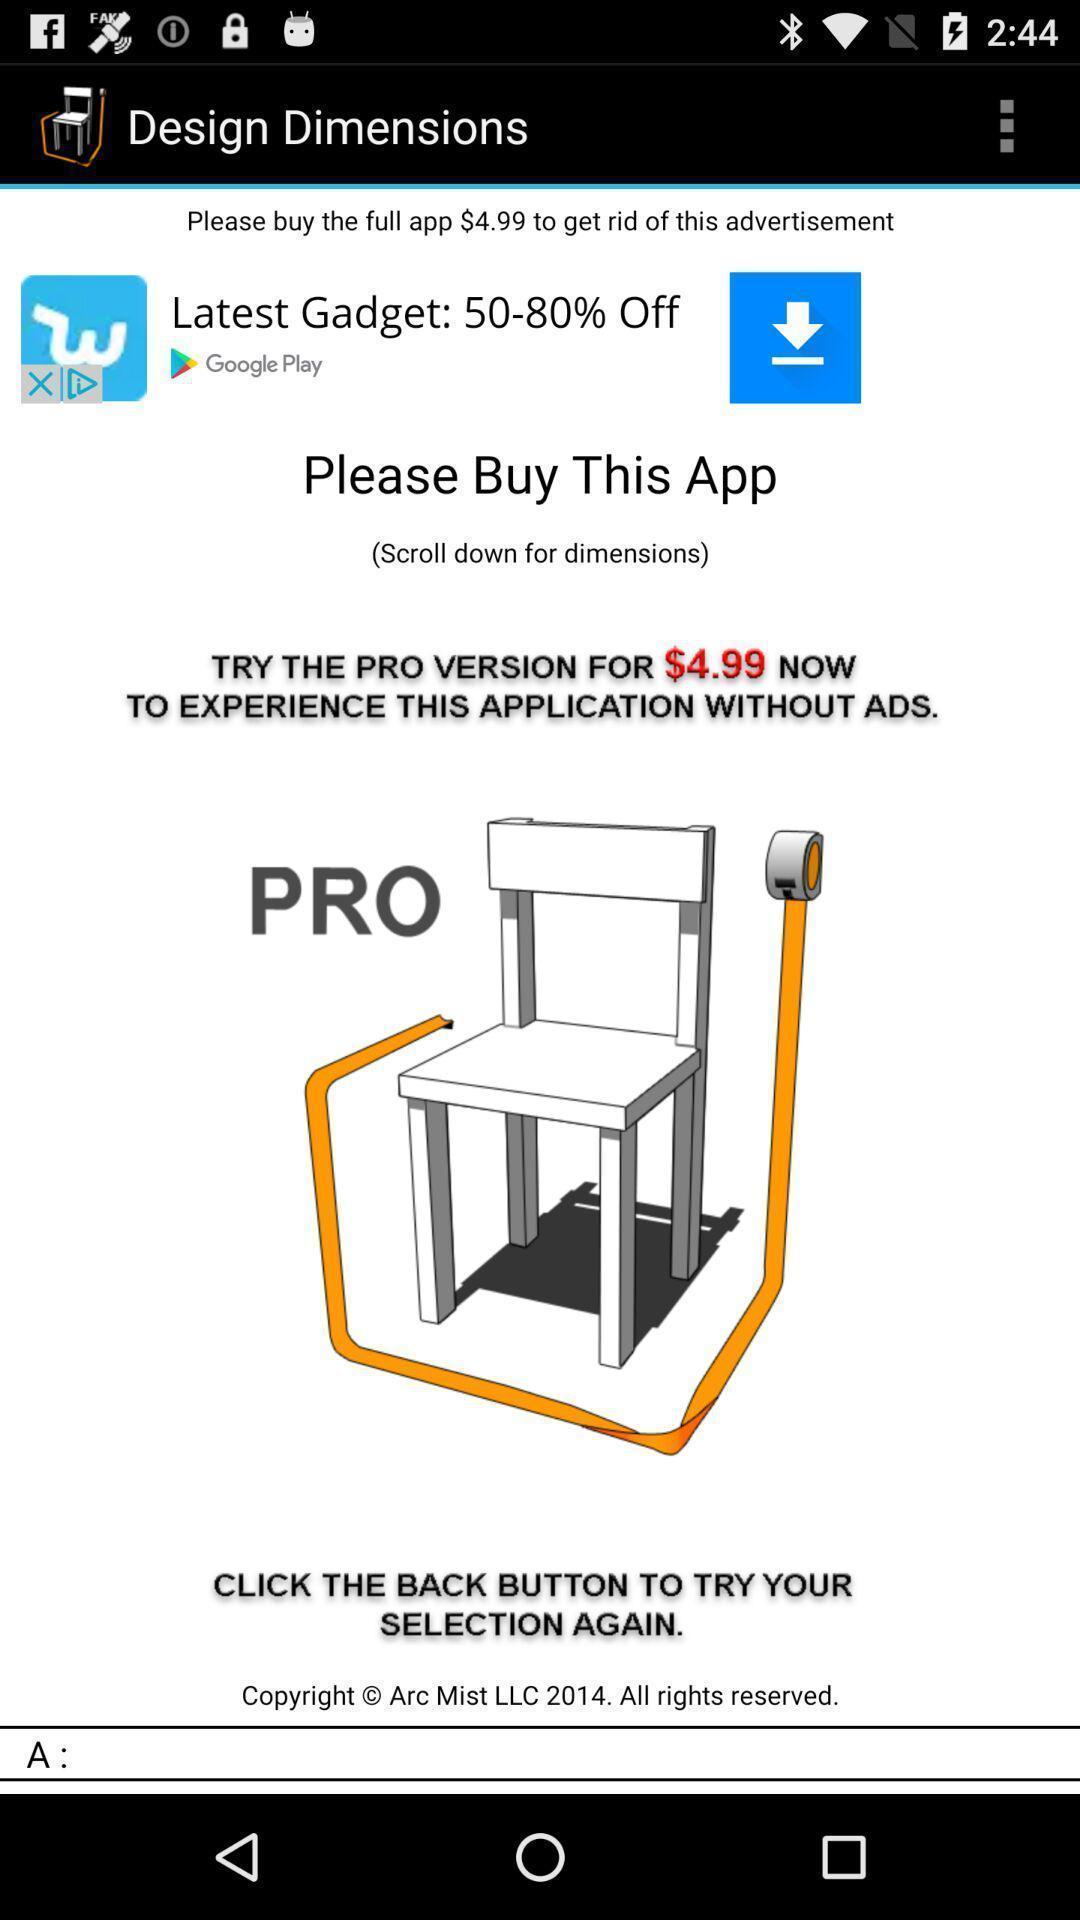Describe the visual elements of this screenshot. Screen displaying information about the application. 